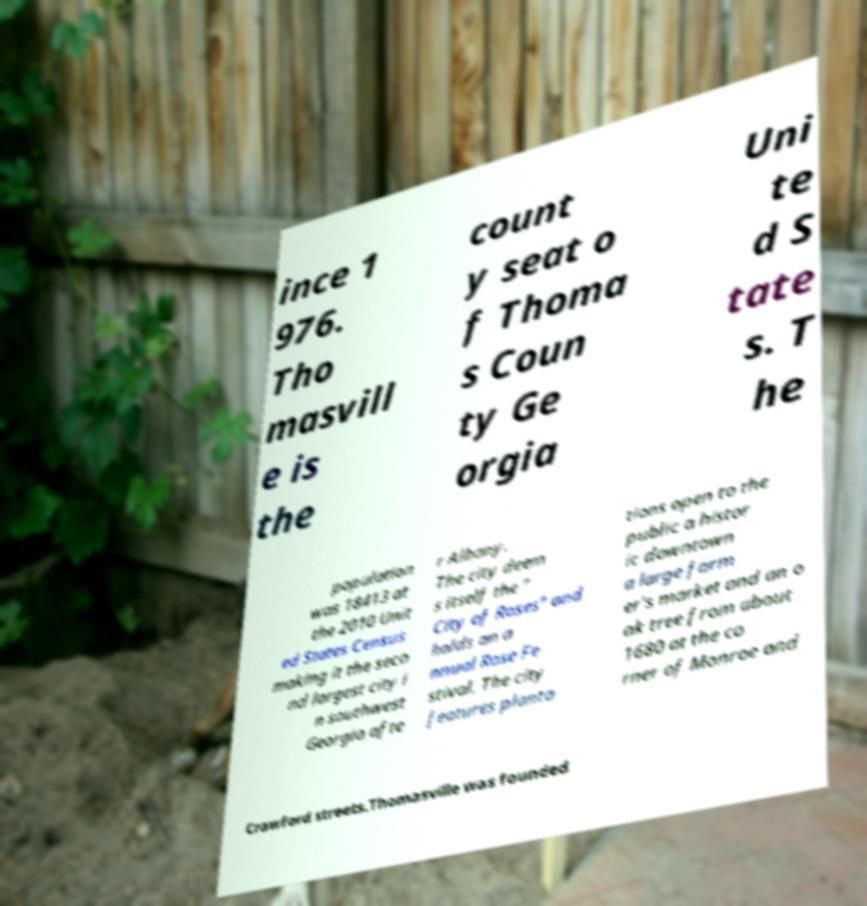For documentation purposes, I need the text within this image transcribed. Could you provide that? ince 1 976. Tho masvill e is the count y seat o f Thoma s Coun ty Ge orgia Uni te d S tate s. T he population was 18413 at the 2010 Unit ed States Census making it the seco nd largest city i n southwest Georgia afte r Albany. The city deem s itself the " City of Roses" and holds an a nnual Rose Fe stival. The city features planta tions open to the public a histor ic downtown a large farm er's market and an o ak tree from about 1680 at the co rner of Monroe and Crawford streets.Thomasville was founded 